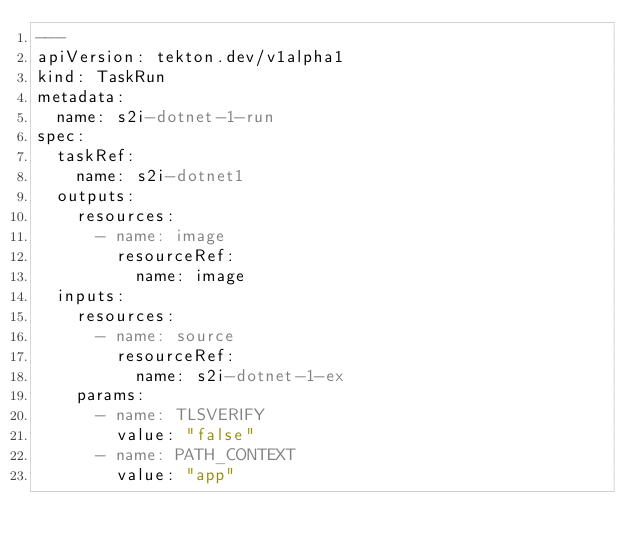Convert code to text. <code><loc_0><loc_0><loc_500><loc_500><_YAML_>---
apiVersion: tekton.dev/v1alpha1
kind: TaskRun
metadata:
  name: s2i-dotnet-1-run
spec:
  taskRef:
    name: s2i-dotnet1
  outputs:
    resources:
      - name: image
        resourceRef:
          name: image
  inputs:
    resources:
      - name: source
        resourceRef:
          name: s2i-dotnet-1-ex
    params:
      - name: TLSVERIFY
        value: "false"
      - name: PATH_CONTEXT
        value: "app"
</code> 